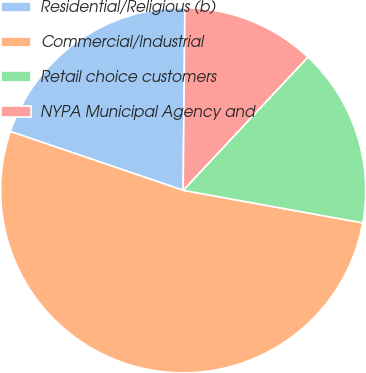Convert chart to OTSL. <chart><loc_0><loc_0><loc_500><loc_500><pie_chart><fcel>Residential/Religious (b)<fcel>Commercial/Industrial<fcel>Retail choice customers<fcel>NYPA Municipal Agency and<nl><fcel>19.93%<fcel>52.36%<fcel>15.88%<fcel>11.82%<nl></chart> 